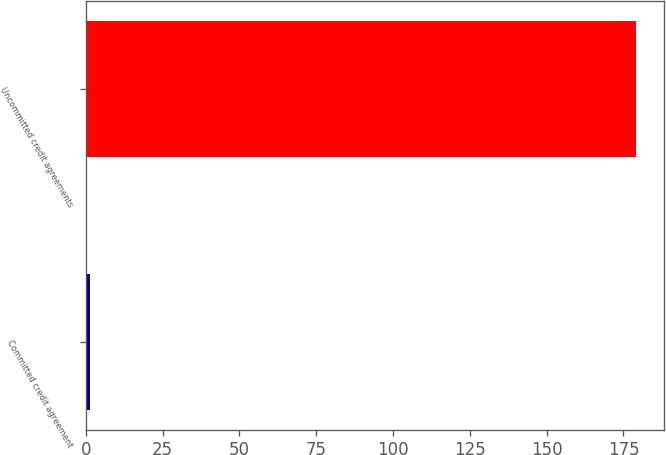Convert chart to OTSL. <chart><loc_0><loc_0><loc_500><loc_500><bar_chart><fcel>Committed credit agreement<fcel>Uncommitted credit agreements<nl><fcel>1.38<fcel>179.1<nl></chart> 